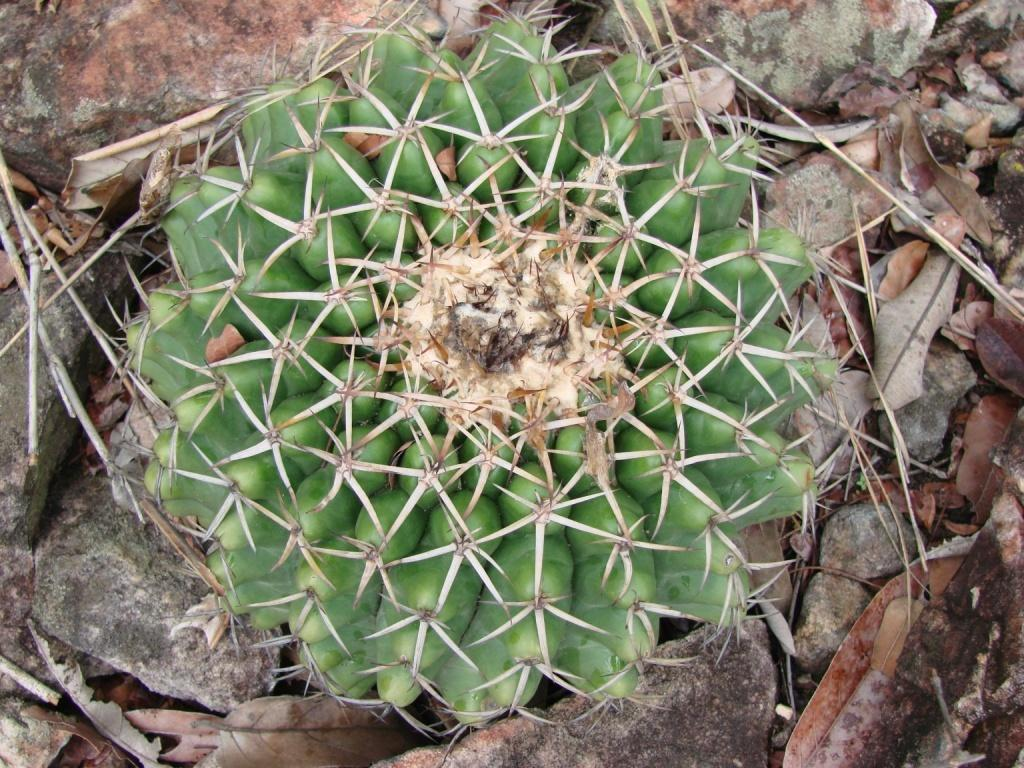What is the main subject in the center of the image? There is a hedgehog cactus in the center of the image. What can be seen in the background of the image? There are dry leaves and stones in the background of the image. What type of bell can be heard ringing in the image? There is no bell present in the image, and therefore no sound can be heard. 